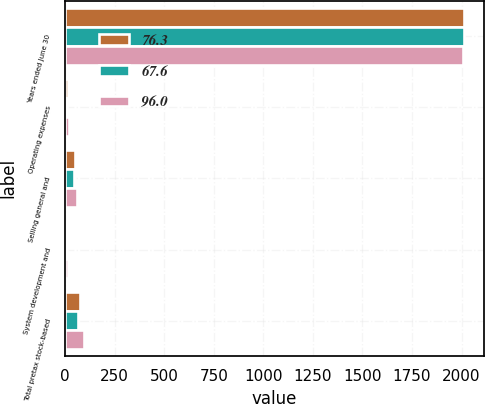<chart> <loc_0><loc_0><loc_500><loc_500><stacked_bar_chart><ecel><fcel>Years ended June 30<fcel>Operating expenses<fcel>Selling general and<fcel>System development and<fcel>Total pretax stock-based<nl><fcel>76.3<fcel>2011<fcel>13.1<fcel>51.8<fcel>11.4<fcel>76.3<nl><fcel>67.6<fcel>2010<fcel>11.7<fcel>45.9<fcel>10<fcel>67.6<nl><fcel>96<fcel>2009<fcel>20.6<fcel>60.4<fcel>15<fcel>96<nl></chart> 